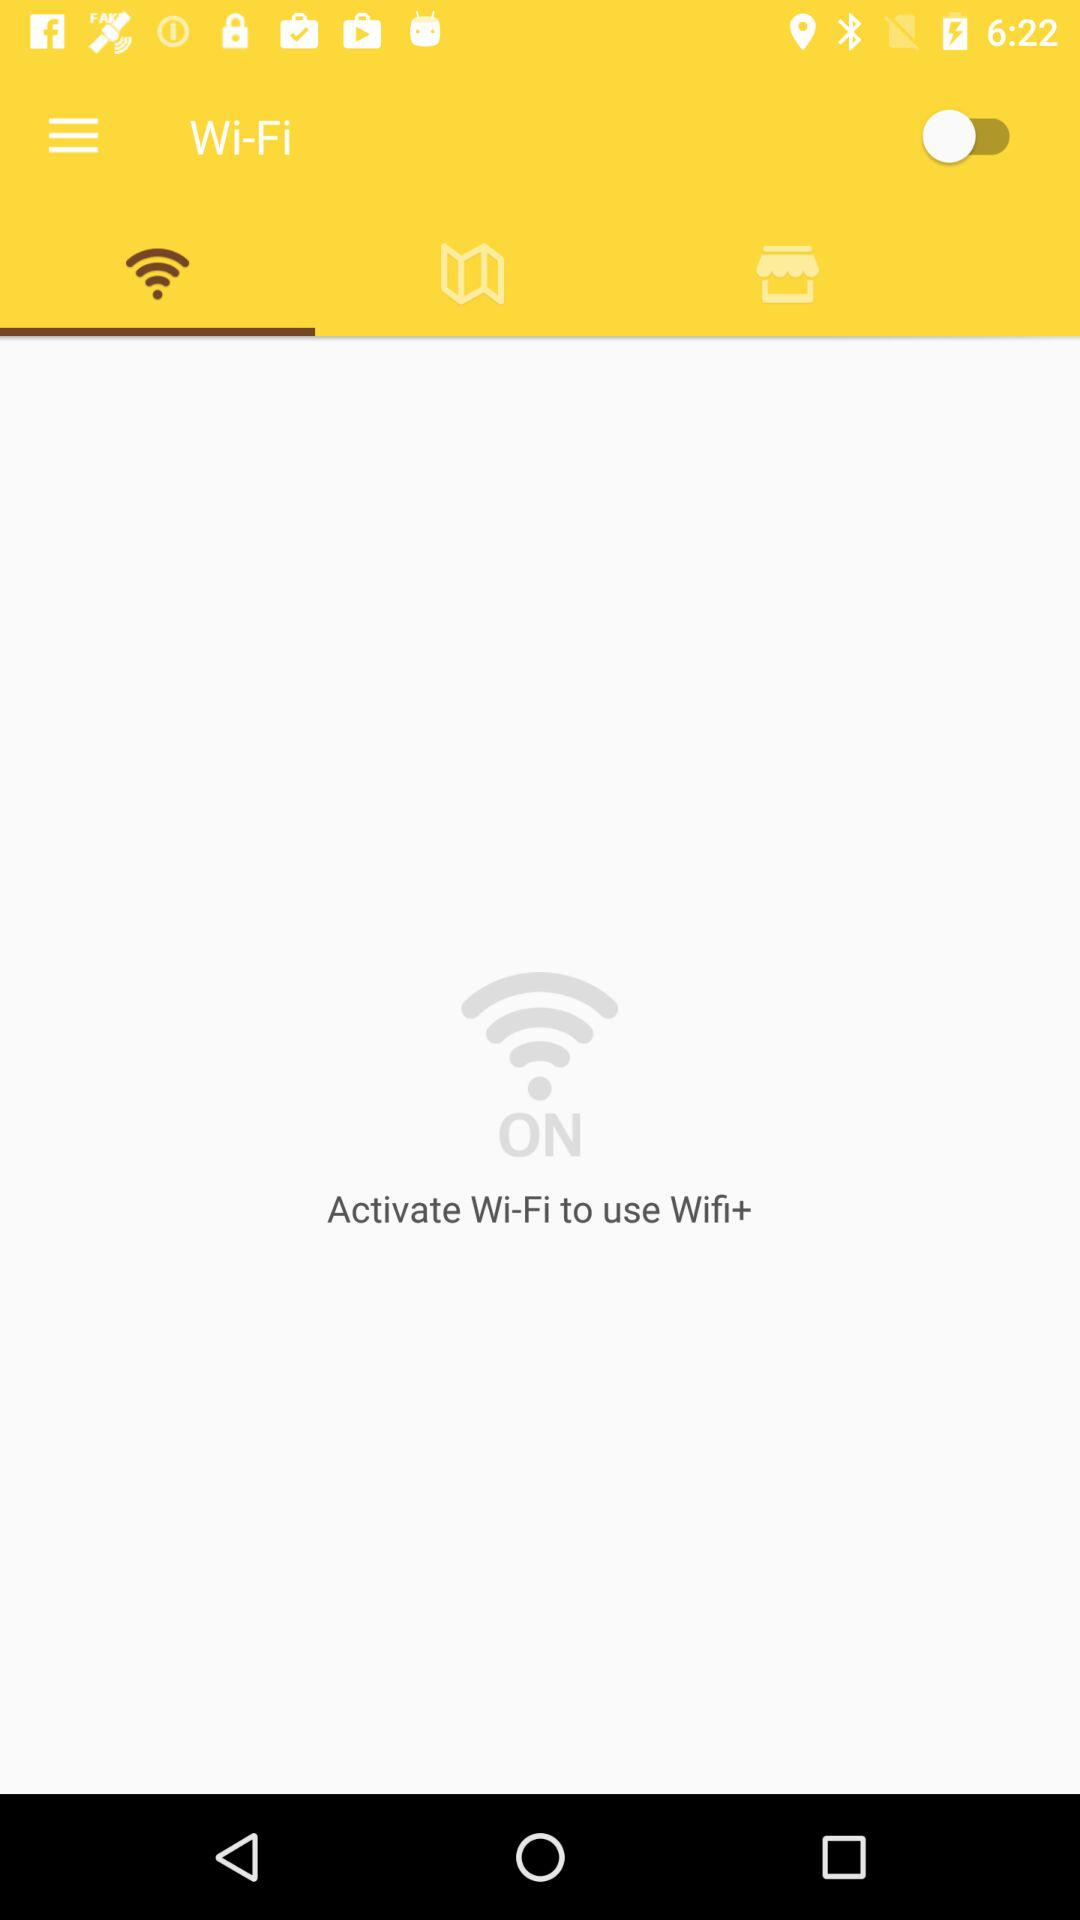Which is the selected WiFi name?
When the provided information is insufficient, respond with <no answer>. <no answer> 